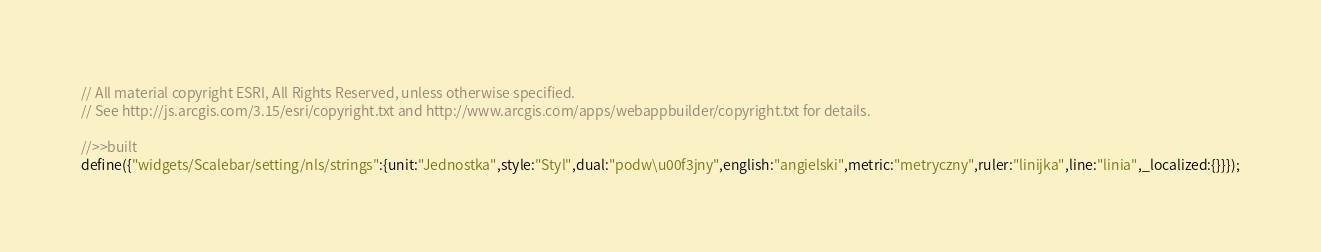Convert code to text. <code><loc_0><loc_0><loc_500><loc_500><_JavaScript_>// All material copyright ESRI, All Rights Reserved, unless otherwise specified.
// See http://js.arcgis.com/3.15/esri/copyright.txt and http://www.arcgis.com/apps/webappbuilder/copyright.txt for details.
//>>built
define({"widgets/Scalebar/setting/nls/strings":{unit:"Jednostka",style:"Styl",dual:"podw\u00f3jny",english:"angielski",metric:"metryczny",ruler:"linijka",line:"linia",_localized:{}}});</code> 